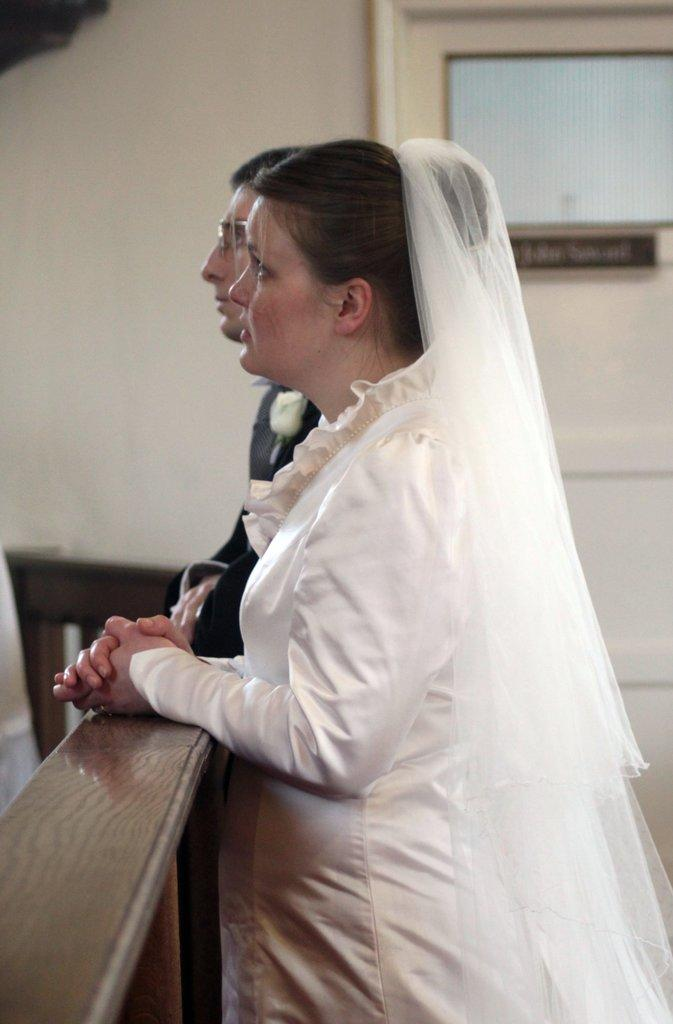How many people are in the image? There are two people in the image, a man and a woman. What are the man and woman doing in the image? The man and woman are standing. What type of furniture is present in the image? There is a wooden table in the image. What can be seen in the background of the image? There is a door and a wall in the background of the image. What type of camp can be seen in the background of the image? There is no camp present in the image; it features a man and a woman standing near a wooden table with a door and a wall in the background. How many toes are visible on the man's foot in the image? The image does not show the man's foot or any toes, so it cannot be determined from the image. 